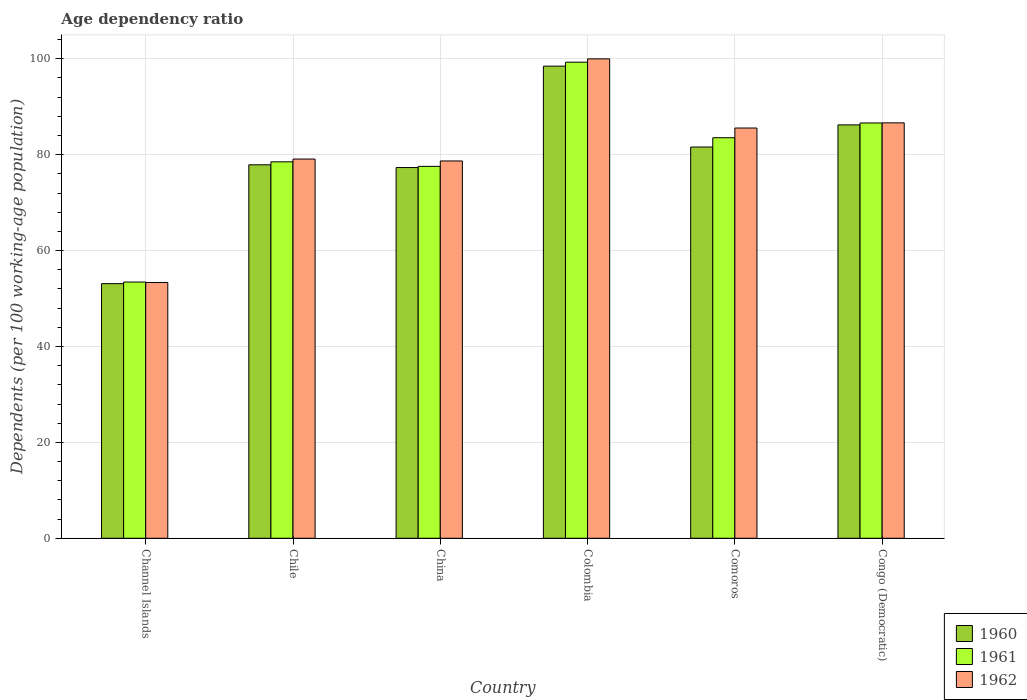How many different coloured bars are there?
Provide a succinct answer. 3. How many groups of bars are there?
Ensure brevity in your answer.  6. What is the label of the 3rd group of bars from the left?
Your response must be concise. China. What is the age dependency ratio in in 1960 in Comoros?
Your response must be concise. 81.6. Across all countries, what is the maximum age dependency ratio in in 1960?
Keep it short and to the point. 98.47. Across all countries, what is the minimum age dependency ratio in in 1960?
Your response must be concise. 53.1. In which country was the age dependency ratio in in 1960 maximum?
Your answer should be compact. Colombia. In which country was the age dependency ratio in in 1962 minimum?
Offer a terse response. Channel Islands. What is the total age dependency ratio in in 1960 in the graph?
Provide a succinct answer. 474.61. What is the difference between the age dependency ratio in in 1962 in Colombia and that in Comoros?
Give a very brief answer. 14.43. What is the difference between the age dependency ratio in in 1960 in Channel Islands and the age dependency ratio in in 1961 in Colombia?
Give a very brief answer. -46.19. What is the average age dependency ratio in in 1962 per country?
Keep it short and to the point. 80.56. What is the difference between the age dependency ratio in of/in 1962 and age dependency ratio in of/in 1960 in Congo (Democratic)?
Provide a succinct answer. 0.43. In how many countries, is the age dependency ratio in in 1962 greater than 28 %?
Your answer should be very brief. 6. What is the ratio of the age dependency ratio in in 1962 in Channel Islands to that in Congo (Democratic)?
Offer a terse response. 0.62. Is the age dependency ratio in in 1960 in Chile less than that in China?
Provide a succinct answer. No. Is the difference between the age dependency ratio in in 1962 in Comoros and Congo (Democratic) greater than the difference between the age dependency ratio in in 1960 in Comoros and Congo (Democratic)?
Offer a very short reply. Yes. What is the difference between the highest and the second highest age dependency ratio in in 1961?
Make the answer very short. -15.75. What is the difference between the highest and the lowest age dependency ratio in in 1962?
Your answer should be very brief. 46.64. In how many countries, is the age dependency ratio in in 1962 greater than the average age dependency ratio in in 1962 taken over all countries?
Provide a short and direct response. 3. Is the sum of the age dependency ratio in in 1960 in Chile and China greater than the maximum age dependency ratio in in 1962 across all countries?
Your response must be concise. Yes. What does the 2nd bar from the right in Channel Islands represents?
Provide a short and direct response. 1961. Is it the case that in every country, the sum of the age dependency ratio in in 1961 and age dependency ratio in in 1960 is greater than the age dependency ratio in in 1962?
Provide a short and direct response. Yes. How many bars are there?
Give a very brief answer. 18. Are all the bars in the graph horizontal?
Make the answer very short. No. How many countries are there in the graph?
Keep it short and to the point. 6. What is the difference between two consecutive major ticks on the Y-axis?
Offer a very short reply. 20. Are the values on the major ticks of Y-axis written in scientific E-notation?
Make the answer very short. No. How many legend labels are there?
Offer a terse response. 3. What is the title of the graph?
Offer a very short reply. Age dependency ratio. Does "1969" appear as one of the legend labels in the graph?
Offer a terse response. No. What is the label or title of the Y-axis?
Provide a succinct answer. Dependents (per 100 working-age population). What is the Dependents (per 100 working-age population) of 1960 in Channel Islands?
Your answer should be very brief. 53.1. What is the Dependents (per 100 working-age population) in 1961 in Channel Islands?
Your response must be concise. 53.44. What is the Dependents (per 100 working-age population) of 1962 in Channel Islands?
Your answer should be very brief. 53.35. What is the Dependents (per 100 working-age population) in 1960 in Chile?
Ensure brevity in your answer.  77.89. What is the Dependents (per 100 working-age population) in 1961 in Chile?
Your answer should be very brief. 78.51. What is the Dependents (per 100 working-age population) of 1962 in Chile?
Provide a short and direct response. 79.09. What is the Dependents (per 100 working-age population) in 1960 in China?
Your answer should be compact. 77.32. What is the Dependents (per 100 working-age population) in 1961 in China?
Offer a very short reply. 77.57. What is the Dependents (per 100 working-age population) in 1962 in China?
Make the answer very short. 78.69. What is the Dependents (per 100 working-age population) in 1960 in Colombia?
Provide a succinct answer. 98.47. What is the Dependents (per 100 working-age population) in 1961 in Colombia?
Your answer should be very brief. 99.29. What is the Dependents (per 100 working-age population) in 1962 in Colombia?
Your answer should be compact. 99.99. What is the Dependents (per 100 working-age population) in 1960 in Comoros?
Offer a very short reply. 81.6. What is the Dependents (per 100 working-age population) in 1961 in Comoros?
Provide a short and direct response. 83.54. What is the Dependents (per 100 working-age population) of 1962 in Comoros?
Your response must be concise. 85.56. What is the Dependents (per 100 working-age population) in 1960 in Congo (Democratic)?
Offer a terse response. 86.22. What is the Dependents (per 100 working-age population) in 1961 in Congo (Democratic)?
Give a very brief answer. 86.62. What is the Dependents (per 100 working-age population) of 1962 in Congo (Democratic)?
Offer a terse response. 86.64. Across all countries, what is the maximum Dependents (per 100 working-age population) of 1960?
Your answer should be very brief. 98.47. Across all countries, what is the maximum Dependents (per 100 working-age population) in 1961?
Provide a succinct answer. 99.29. Across all countries, what is the maximum Dependents (per 100 working-age population) of 1962?
Make the answer very short. 99.99. Across all countries, what is the minimum Dependents (per 100 working-age population) of 1960?
Your answer should be compact. 53.1. Across all countries, what is the minimum Dependents (per 100 working-age population) in 1961?
Offer a very short reply. 53.44. Across all countries, what is the minimum Dependents (per 100 working-age population) in 1962?
Make the answer very short. 53.35. What is the total Dependents (per 100 working-age population) in 1960 in the graph?
Offer a very short reply. 474.61. What is the total Dependents (per 100 working-age population) of 1961 in the graph?
Your response must be concise. 478.97. What is the total Dependents (per 100 working-age population) of 1962 in the graph?
Your answer should be compact. 483.33. What is the difference between the Dependents (per 100 working-age population) in 1960 in Channel Islands and that in Chile?
Your answer should be compact. -24.79. What is the difference between the Dependents (per 100 working-age population) of 1961 in Channel Islands and that in Chile?
Your response must be concise. -25.07. What is the difference between the Dependents (per 100 working-age population) of 1962 in Channel Islands and that in Chile?
Ensure brevity in your answer.  -25.74. What is the difference between the Dependents (per 100 working-age population) in 1960 in Channel Islands and that in China?
Keep it short and to the point. -24.22. What is the difference between the Dependents (per 100 working-age population) of 1961 in Channel Islands and that in China?
Your response must be concise. -24.13. What is the difference between the Dependents (per 100 working-age population) in 1962 in Channel Islands and that in China?
Give a very brief answer. -25.34. What is the difference between the Dependents (per 100 working-age population) of 1960 in Channel Islands and that in Colombia?
Ensure brevity in your answer.  -45.36. What is the difference between the Dependents (per 100 working-age population) of 1961 in Channel Islands and that in Colombia?
Offer a terse response. -45.85. What is the difference between the Dependents (per 100 working-age population) in 1962 in Channel Islands and that in Colombia?
Your response must be concise. -46.64. What is the difference between the Dependents (per 100 working-age population) in 1960 in Channel Islands and that in Comoros?
Your answer should be very brief. -28.5. What is the difference between the Dependents (per 100 working-age population) of 1961 in Channel Islands and that in Comoros?
Offer a terse response. -30.1. What is the difference between the Dependents (per 100 working-age population) in 1962 in Channel Islands and that in Comoros?
Provide a short and direct response. -32.21. What is the difference between the Dependents (per 100 working-age population) in 1960 in Channel Islands and that in Congo (Democratic)?
Your response must be concise. -33.11. What is the difference between the Dependents (per 100 working-age population) of 1961 in Channel Islands and that in Congo (Democratic)?
Your response must be concise. -33.18. What is the difference between the Dependents (per 100 working-age population) of 1962 in Channel Islands and that in Congo (Democratic)?
Make the answer very short. -33.29. What is the difference between the Dependents (per 100 working-age population) in 1960 in Chile and that in China?
Keep it short and to the point. 0.57. What is the difference between the Dependents (per 100 working-age population) in 1961 in Chile and that in China?
Your answer should be compact. 0.95. What is the difference between the Dependents (per 100 working-age population) of 1962 in Chile and that in China?
Provide a succinct answer. 0.4. What is the difference between the Dependents (per 100 working-age population) of 1960 in Chile and that in Colombia?
Make the answer very short. -20.58. What is the difference between the Dependents (per 100 working-age population) of 1961 in Chile and that in Colombia?
Offer a very short reply. -20.78. What is the difference between the Dependents (per 100 working-age population) in 1962 in Chile and that in Colombia?
Make the answer very short. -20.9. What is the difference between the Dependents (per 100 working-age population) of 1960 in Chile and that in Comoros?
Offer a very short reply. -3.71. What is the difference between the Dependents (per 100 working-age population) in 1961 in Chile and that in Comoros?
Ensure brevity in your answer.  -5.03. What is the difference between the Dependents (per 100 working-age population) in 1962 in Chile and that in Comoros?
Keep it short and to the point. -6.47. What is the difference between the Dependents (per 100 working-age population) in 1960 in Chile and that in Congo (Democratic)?
Provide a short and direct response. -8.32. What is the difference between the Dependents (per 100 working-age population) in 1961 in Chile and that in Congo (Democratic)?
Offer a very short reply. -8.1. What is the difference between the Dependents (per 100 working-age population) in 1962 in Chile and that in Congo (Democratic)?
Your answer should be compact. -7.55. What is the difference between the Dependents (per 100 working-age population) of 1960 in China and that in Colombia?
Offer a terse response. -21.15. What is the difference between the Dependents (per 100 working-age population) in 1961 in China and that in Colombia?
Offer a very short reply. -21.73. What is the difference between the Dependents (per 100 working-age population) of 1962 in China and that in Colombia?
Keep it short and to the point. -21.3. What is the difference between the Dependents (per 100 working-age population) of 1960 in China and that in Comoros?
Keep it short and to the point. -4.28. What is the difference between the Dependents (per 100 working-age population) of 1961 in China and that in Comoros?
Offer a terse response. -5.97. What is the difference between the Dependents (per 100 working-age population) of 1962 in China and that in Comoros?
Provide a short and direct response. -6.87. What is the difference between the Dependents (per 100 working-age population) of 1960 in China and that in Congo (Democratic)?
Keep it short and to the point. -8.89. What is the difference between the Dependents (per 100 working-age population) in 1961 in China and that in Congo (Democratic)?
Your answer should be compact. -9.05. What is the difference between the Dependents (per 100 working-age population) in 1962 in China and that in Congo (Democratic)?
Offer a terse response. -7.95. What is the difference between the Dependents (per 100 working-age population) in 1960 in Colombia and that in Comoros?
Keep it short and to the point. 16.87. What is the difference between the Dependents (per 100 working-age population) in 1961 in Colombia and that in Comoros?
Your answer should be very brief. 15.75. What is the difference between the Dependents (per 100 working-age population) of 1962 in Colombia and that in Comoros?
Provide a short and direct response. 14.43. What is the difference between the Dependents (per 100 working-age population) in 1960 in Colombia and that in Congo (Democratic)?
Your answer should be compact. 12.25. What is the difference between the Dependents (per 100 working-age population) of 1961 in Colombia and that in Congo (Democratic)?
Give a very brief answer. 12.68. What is the difference between the Dependents (per 100 working-age population) in 1962 in Colombia and that in Congo (Democratic)?
Your answer should be compact. 13.35. What is the difference between the Dependents (per 100 working-age population) of 1960 in Comoros and that in Congo (Democratic)?
Provide a succinct answer. -4.61. What is the difference between the Dependents (per 100 working-age population) in 1961 in Comoros and that in Congo (Democratic)?
Provide a succinct answer. -3.08. What is the difference between the Dependents (per 100 working-age population) of 1962 in Comoros and that in Congo (Democratic)?
Offer a very short reply. -1.08. What is the difference between the Dependents (per 100 working-age population) in 1960 in Channel Islands and the Dependents (per 100 working-age population) in 1961 in Chile?
Ensure brevity in your answer.  -25.41. What is the difference between the Dependents (per 100 working-age population) in 1960 in Channel Islands and the Dependents (per 100 working-age population) in 1962 in Chile?
Make the answer very short. -25.99. What is the difference between the Dependents (per 100 working-age population) of 1961 in Channel Islands and the Dependents (per 100 working-age population) of 1962 in Chile?
Offer a terse response. -25.65. What is the difference between the Dependents (per 100 working-age population) in 1960 in Channel Islands and the Dependents (per 100 working-age population) in 1961 in China?
Provide a short and direct response. -24.46. What is the difference between the Dependents (per 100 working-age population) of 1960 in Channel Islands and the Dependents (per 100 working-age population) of 1962 in China?
Make the answer very short. -25.59. What is the difference between the Dependents (per 100 working-age population) in 1961 in Channel Islands and the Dependents (per 100 working-age population) in 1962 in China?
Ensure brevity in your answer.  -25.25. What is the difference between the Dependents (per 100 working-age population) in 1960 in Channel Islands and the Dependents (per 100 working-age population) in 1961 in Colombia?
Provide a succinct answer. -46.19. What is the difference between the Dependents (per 100 working-age population) in 1960 in Channel Islands and the Dependents (per 100 working-age population) in 1962 in Colombia?
Provide a succinct answer. -46.89. What is the difference between the Dependents (per 100 working-age population) of 1961 in Channel Islands and the Dependents (per 100 working-age population) of 1962 in Colombia?
Your response must be concise. -46.55. What is the difference between the Dependents (per 100 working-age population) in 1960 in Channel Islands and the Dependents (per 100 working-age population) in 1961 in Comoros?
Ensure brevity in your answer.  -30.44. What is the difference between the Dependents (per 100 working-age population) of 1960 in Channel Islands and the Dependents (per 100 working-age population) of 1962 in Comoros?
Your answer should be compact. -32.46. What is the difference between the Dependents (per 100 working-age population) of 1961 in Channel Islands and the Dependents (per 100 working-age population) of 1962 in Comoros?
Provide a short and direct response. -32.12. What is the difference between the Dependents (per 100 working-age population) in 1960 in Channel Islands and the Dependents (per 100 working-age population) in 1961 in Congo (Democratic)?
Keep it short and to the point. -33.51. What is the difference between the Dependents (per 100 working-age population) in 1960 in Channel Islands and the Dependents (per 100 working-age population) in 1962 in Congo (Democratic)?
Your answer should be compact. -33.54. What is the difference between the Dependents (per 100 working-age population) of 1961 in Channel Islands and the Dependents (per 100 working-age population) of 1962 in Congo (Democratic)?
Provide a short and direct response. -33.2. What is the difference between the Dependents (per 100 working-age population) of 1960 in Chile and the Dependents (per 100 working-age population) of 1961 in China?
Your answer should be compact. 0.33. What is the difference between the Dependents (per 100 working-age population) in 1960 in Chile and the Dependents (per 100 working-age population) in 1962 in China?
Your answer should be very brief. -0.8. What is the difference between the Dependents (per 100 working-age population) in 1961 in Chile and the Dependents (per 100 working-age population) in 1962 in China?
Ensure brevity in your answer.  -0.18. What is the difference between the Dependents (per 100 working-age population) of 1960 in Chile and the Dependents (per 100 working-age population) of 1961 in Colombia?
Your answer should be compact. -21.4. What is the difference between the Dependents (per 100 working-age population) in 1960 in Chile and the Dependents (per 100 working-age population) in 1962 in Colombia?
Keep it short and to the point. -22.1. What is the difference between the Dependents (per 100 working-age population) in 1961 in Chile and the Dependents (per 100 working-age population) in 1962 in Colombia?
Provide a short and direct response. -21.48. What is the difference between the Dependents (per 100 working-age population) of 1960 in Chile and the Dependents (per 100 working-age population) of 1961 in Comoros?
Give a very brief answer. -5.65. What is the difference between the Dependents (per 100 working-age population) in 1960 in Chile and the Dependents (per 100 working-age population) in 1962 in Comoros?
Keep it short and to the point. -7.67. What is the difference between the Dependents (per 100 working-age population) in 1961 in Chile and the Dependents (per 100 working-age population) in 1962 in Comoros?
Your answer should be compact. -7.05. What is the difference between the Dependents (per 100 working-age population) of 1960 in Chile and the Dependents (per 100 working-age population) of 1961 in Congo (Democratic)?
Your response must be concise. -8.72. What is the difference between the Dependents (per 100 working-age population) in 1960 in Chile and the Dependents (per 100 working-age population) in 1962 in Congo (Democratic)?
Your answer should be compact. -8.75. What is the difference between the Dependents (per 100 working-age population) in 1961 in Chile and the Dependents (per 100 working-age population) in 1962 in Congo (Democratic)?
Your answer should be very brief. -8.13. What is the difference between the Dependents (per 100 working-age population) of 1960 in China and the Dependents (per 100 working-age population) of 1961 in Colombia?
Provide a succinct answer. -21.97. What is the difference between the Dependents (per 100 working-age population) in 1960 in China and the Dependents (per 100 working-age population) in 1962 in Colombia?
Offer a terse response. -22.67. What is the difference between the Dependents (per 100 working-age population) of 1961 in China and the Dependents (per 100 working-age population) of 1962 in Colombia?
Make the answer very short. -22.42. What is the difference between the Dependents (per 100 working-age population) in 1960 in China and the Dependents (per 100 working-age population) in 1961 in Comoros?
Offer a very short reply. -6.22. What is the difference between the Dependents (per 100 working-age population) in 1960 in China and the Dependents (per 100 working-age population) in 1962 in Comoros?
Keep it short and to the point. -8.24. What is the difference between the Dependents (per 100 working-age population) in 1961 in China and the Dependents (per 100 working-age population) in 1962 in Comoros?
Give a very brief answer. -8. What is the difference between the Dependents (per 100 working-age population) of 1960 in China and the Dependents (per 100 working-age population) of 1961 in Congo (Democratic)?
Your answer should be compact. -9.3. What is the difference between the Dependents (per 100 working-age population) of 1960 in China and the Dependents (per 100 working-age population) of 1962 in Congo (Democratic)?
Offer a very short reply. -9.32. What is the difference between the Dependents (per 100 working-age population) of 1961 in China and the Dependents (per 100 working-age population) of 1962 in Congo (Democratic)?
Your answer should be compact. -9.07. What is the difference between the Dependents (per 100 working-age population) in 1960 in Colombia and the Dependents (per 100 working-age population) in 1961 in Comoros?
Ensure brevity in your answer.  14.93. What is the difference between the Dependents (per 100 working-age population) in 1960 in Colombia and the Dependents (per 100 working-age population) in 1962 in Comoros?
Provide a succinct answer. 12.91. What is the difference between the Dependents (per 100 working-age population) in 1961 in Colombia and the Dependents (per 100 working-age population) in 1962 in Comoros?
Your answer should be compact. 13.73. What is the difference between the Dependents (per 100 working-age population) in 1960 in Colombia and the Dependents (per 100 working-age population) in 1961 in Congo (Democratic)?
Your answer should be very brief. 11.85. What is the difference between the Dependents (per 100 working-age population) in 1960 in Colombia and the Dependents (per 100 working-age population) in 1962 in Congo (Democratic)?
Provide a short and direct response. 11.83. What is the difference between the Dependents (per 100 working-age population) in 1961 in Colombia and the Dependents (per 100 working-age population) in 1962 in Congo (Democratic)?
Provide a short and direct response. 12.65. What is the difference between the Dependents (per 100 working-age population) in 1960 in Comoros and the Dependents (per 100 working-age population) in 1961 in Congo (Democratic)?
Your response must be concise. -5.02. What is the difference between the Dependents (per 100 working-age population) of 1960 in Comoros and the Dependents (per 100 working-age population) of 1962 in Congo (Democratic)?
Ensure brevity in your answer.  -5.04. What is the difference between the Dependents (per 100 working-age population) in 1961 in Comoros and the Dependents (per 100 working-age population) in 1962 in Congo (Democratic)?
Give a very brief answer. -3.1. What is the average Dependents (per 100 working-age population) of 1960 per country?
Give a very brief answer. 79.1. What is the average Dependents (per 100 working-age population) in 1961 per country?
Make the answer very short. 79.83. What is the average Dependents (per 100 working-age population) in 1962 per country?
Ensure brevity in your answer.  80.56. What is the difference between the Dependents (per 100 working-age population) in 1960 and Dependents (per 100 working-age population) in 1961 in Channel Islands?
Make the answer very short. -0.34. What is the difference between the Dependents (per 100 working-age population) of 1960 and Dependents (per 100 working-age population) of 1962 in Channel Islands?
Your response must be concise. -0.24. What is the difference between the Dependents (per 100 working-age population) in 1961 and Dependents (per 100 working-age population) in 1962 in Channel Islands?
Offer a terse response. 0.09. What is the difference between the Dependents (per 100 working-age population) of 1960 and Dependents (per 100 working-age population) of 1961 in Chile?
Your response must be concise. -0.62. What is the difference between the Dependents (per 100 working-age population) of 1960 and Dependents (per 100 working-age population) of 1962 in Chile?
Your response must be concise. -1.2. What is the difference between the Dependents (per 100 working-age population) in 1961 and Dependents (per 100 working-age population) in 1962 in Chile?
Ensure brevity in your answer.  -0.58. What is the difference between the Dependents (per 100 working-age population) of 1960 and Dependents (per 100 working-age population) of 1961 in China?
Provide a short and direct response. -0.24. What is the difference between the Dependents (per 100 working-age population) of 1960 and Dependents (per 100 working-age population) of 1962 in China?
Your answer should be compact. -1.37. What is the difference between the Dependents (per 100 working-age population) of 1961 and Dependents (per 100 working-age population) of 1962 in China?
Offer a very short reply. -1.13. What is the difference between the Dependents (per 100 working-age population) in 1960 and Dependents (per 100 working-age population) in 1961 in Colombia?
Give a very brief answer. -0.82. What is the difference between the Dependents (per 100 working-age population) in 1960 and Dependents (per 100 working-age population) in 1962 in Colombia?
Give a very brief answer. -1.52. What is the difference between the Dependents (per 100 working-age population) in 1961 and Dependents (per 100 working-age population) in 1962 in Colombia?
Your answer should be compact. -0.7. What is the difference between the Dependents (per 100 working-age population) of 1960 and Dependents (per 100 working-age population) of 1961 in Comoros?
Your response must be concise. -1.94. What is the difference between the Dependents (per 100 working-age population) in 1960 and Dependents (per 100 working-age population) in 1962 in Comoros?
Keep it short and to the point. -3.96. What is the difference between the Dependents (per 100 working-age population) in 1961 and Dependents (per 100 working-age population) in 1962 in Comoros?
Keep it short and to the point. -2.02. What is the difference between the Dependents (per 100 working-age population) in 1960 and Dependents (per 100 working-age population) in 1961 in Congo (Democratic)?
Make the answer very short. -0.4. What is the difference between the Dependents (per 100 working-age population) of 1960 and Dependents (per 100 working-age population) of 1962 in Congo (Democratic)?
Provide a succinct answer. -0.43. What is the difference between the Dependents (per 100 working-age population) in 1961 and Dependents (per 100 working-age population) in 1962 in Congo (Democratic)?
Give a very brief answer. -0.02. What is the ratio of the Dependents (per 100 working-age population) in 1960 in Channel Islands to that in Chile?
Keep it short and to the point. 0.68. What is the ratio of the Dependents (per 100 working-age population) of 1961 in Channel Islands to that in Chile?
Your answer should be very brief. 0.68. What is the ratio of the Dependents (per 100 working-age population) of 1962 in Channel Islands to that in Chile?
Provide a succinct answer. 0.67. What is the ratio of the Dependents (per 100 working-age population) of 1960 in Channel Islands to that in China?
Make the answer very short. 0.69. What is the ratio of the Dependents (per 100 working-age population) of 1961 in Channel Islands to that in China?
Ensure brevity in your answer.  0.69. What is the ratio of the Dependents (per 100 working-age population) in 1962 in Channel Islands to that in China?
Your answer should be compact. 0.68. What is the ratio of the Dependents (per 100 working-age population) of 1960 in Channel Islands to that in Colombia?
Your answer should be very brief. 0.54. What is the ratio of the Dependents (per 100 working-age population) of 1961 in Channel Islands to that in Colombia?
Provide a succinct answer. 0.54. What is the ratio of the Dependents (per 100 working-age population) of 1962 in Channel Islands to that in Colombia?
Provide a short and direct response. 0.53. What is the ratio of the Dependents (per 100 working-age population) in 1960 in Channel Islands to that in Comoros?
Make the answer very short. 0.65. What is the ratio of the Dependents (per 100 working-age population) in 1961 in Channel Islands to that in Comoros?
Make the answer very short. 0.64. What is the ratio of the Dependents (per 100 working-age population) in 1962 in Channel Islands to that in Comoros?
Your response must be concise. 0.62. What is the ratio of the Dependents (per 100 working-age population) in 1960 in Channel Islands to that in Congo (Democratic)?
Make the answer very short. 0.62. What is the ratio of the Dependents (per 100 working-age population) in 1961 in Channel Islands to that in Congo (Democratic)?
Offer a very short reply. 0.62. What is the ratio of the Dependents (per 100 working-age population) in 1962 in Channel Islands to that in Congo (Democratic)?
Give a very brief answer. 0.62. What is the ratio of the Dependents (per 100 working-age population) of 1960 in Chile to that in China?
Provide a succinct answer. 1.01. What is the ratio of the Dependents (per 100 working-age population) in 1961 in Chile to that in China?
Provide a short and direct response. 1.01. What is the ratio of the Dependents (per 100 working-age population) of 1962 in Chile to that in China?
Offer a terse response. 1.01. What is the ratio of the Dependents (per 100 working-age population) of 1960 in Chile to that in Colombia?
Make the answer very short. 0.79. What is the ratio of the Dependents (per 100 working-age population) of 1961 in Chile to that in Colombia?
Offer a terse response. 0.79. What is the ratio of the Dependents (per 100 working-age population) in 1962 in Chile to that in Colombia?
Your answer should be compact. 0.79. What is the ratio of the Dependents (per 100 working-age population) in 1960 in Chile to that in Comoros?
Provide a succinct answer. 0.95. What is the ratio of the Dependents (per 100 working-age population) in 1961 in Chile to that in Comoros?
Give a very brief answer. 0.94. What is the ratio of the Dependents (per 100 working-age population) of 1962 in Chile to that in Comoros?
Keep it short and to the point. 0.92. What is the ratio of the Dependents (per 100 working-age population) in 1960 in Chile to that in Congo (Democratic)?
Give a very brief answer. 0.9. What is the ratio of the Dependents (per 100 working-age population) of 1961 in Chile to that in Congo (Democratic)?
Provide a succinct answer. 0.91. What is the ratio of the Dependents (per 100 working-age population) in 1962 in Chile to that in Congo (Democratic)?
Offer a very short reply. 0.91. What is the ratio of the Dependents (per 100 working-age population) in 1960 in China to that in Colombia?
Make the answer very short. 0.79. What is the ratio of the Dependents (per 100 working-age population) in 1961 in China to that in Colombia?
Ensure brevity in your answer.  0.78. What is the ratio of the Dependents (per 100 working-age population) of 1962 in China to that in Colombia?
Your response must be concise. 0.79. What is the ratio of the Dependents (per 100 working-age population) of 1960 in China to that in Comoros?
Provide a succinct answer. 0.95. What is the ratio of the Dependents (per 100 working-age population) of 1961 in China to that in Comoros?
Provide a succinct answer. 0.93. What is the ratio of the Dependents (per 100 working-age population) in 1962 in China to that in Comoros?
Your answer should be compact. 0.92. What is the ratio of the Dependents (per 100 working-age population) in 1960 in China to that in Congo (Democratic)?
Your response must be concise. 0.9. What is the ratio of the Dependents (per 100 working-age population) in 1961 in China to that in Congo (Democratic)?
Provide a succinct answer. 0.9. What is the ratio of the Dependents (per 100 working-age population) of 1962 in China to that in Congo (Democratic)?
Offer a terse response. 0.91. What is the ratio of the Dependents (per 100 working-age population) of 1960 in Colombia to that in Comoros?
Offer a very short reply. 1.21. What is the ratio of the Dependents (per 100 working-age population) of 1961 in Colombia to that in Comoros?
Give a very brief answer. 1.19. What is the ratio of the Dependents (per 100 working-age population) in 1962 in Colombia to that in Comoros?
Your response must be concise. 1.17. What is the ratio of the Dependents (per 100 working-age population) of 1960 in Colombia to that in Congo (Democratic)?
Give a very brief answer. 1.14. What is the ratio of the Dependents (per 100 working-age population) in 1961 in Colombia to that in Congo (Democratic)?
Ensure brevity in your answer.  1.15. What is the ratio of the Dependents (per 100 working-age population) in 1962 in Colombia to that in Congo (Democratic)?
Your response must be concise. 1.15. What is the ratio of the Dependents (per 100 working-age population) in 1960 in Comoros to that in Congo (Democratic)?
Provide a short and direct response. 0.95. What is the ratio of the Dependents (per 100 working-age population) of 1961 in Comoros to that in Congo (Democratic)?
Your answer should be very brief. 0.96. What is the ratio of the Dependents (per 100 working-age population) in 1962 in Comoros to that in Congo (Democratic)?
Your answer should be compact. 0.99. What is the difference between the highest and the second highest Dependents (per 100 working-age population) of 1960?
Keep it short and to the point. 12.25. What is the difference between the highest and the second highest Dependents (per 100 working-age population) of 1961?
Offer a terse response. 12.68. What is the difference between the highest and the second highest Dependents (per 100 working-age population) of 1962?
Offer a very short reply. 13.35. What is the difference between the highest and the lowest Dependents (per 100 working-age population) in 1960?
Your answer should be compact. 45.36. What is the difference between the highest and the lowest Dependents (per 100 working-age population) of 1961?
Make the answer very short. 45.85. What is the difference between the highest and the lowest Dependents (per 100 working-age population) of 1962?
Your answer should be very brief. 46.64. 